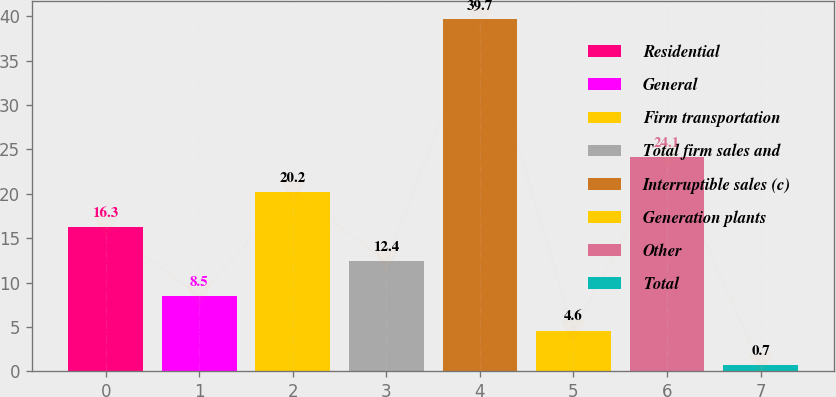<chart> <loc_0><loc_0><loc_500><loc_500><bar_chart><fcel>Residential<fcel>General<fcel>Firm transportation<fcel>Total firm sales and<fcel>Interruptible sales (c)<fcel>Generation plants<fcel>Other<fcel>Total<nl><fcel>16.3<fcel>8.5<fcel>20.2<fcel>12.4<fcel>39.7<fcel>4.6<fcel>24.1<fcel>0.7<nl></chart> 